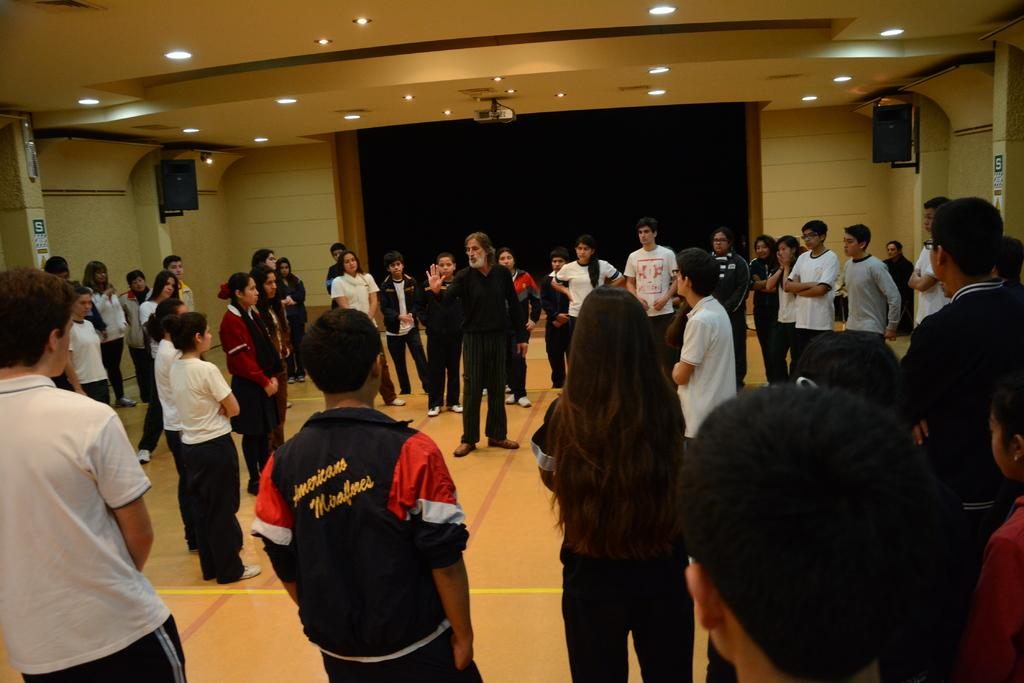What are the people in the image doing? There is a group of people on the floor in the image. What objects can be seen in the image besides the people? There are boards, speakers, and lights visible in the image. What is the background of the image? There is a wall in the background of the image. Can you see a wrench being used by anyone in the image? There is no wrench present in the image. What type of amusement can be seen in the image? There is no amusement depicted in the image; it features a group of people on the floor with various objects. Are there any people kissing in the image? There is no indication of anyone kissing in the image. 